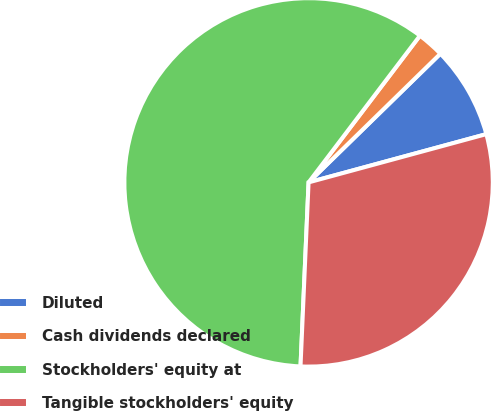Convert chart. <chart><loc_0><loc_0><loc_500><loc_500><pie_chart><fcel>Diluted<fcel>Cash dividends declared<fcel>Stockholders' equity at<fcel>Tangible stockholders' equity<nl><fcel>8.09%<fcel>2.36%<fcel>59.64%<fcel>29.92%<nl></chart> 